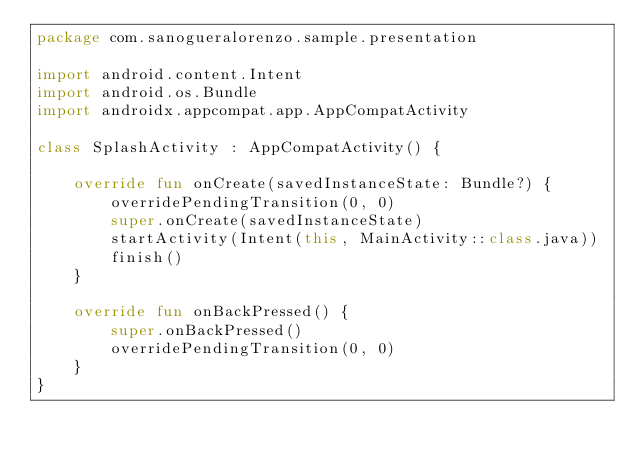<code> <loc_0><loc_0><loc_500><loc_500><_Kotlin_>package com.sanogueralorenzo.sample.presentation

import android.content.Intent
import android.os.Bundle
import androidx.appcompat.app.AppCompatActivity

class SplashActivity : AppCompatActivity() {

    override fun onCreate(savedInstanceState: Bundle?) {
        overridePendingTransition(0, 0)
        super.onCreate(savedInstanceState)
        startActivity(Intent(this, MainActivity::class.java))
        finish()
    }

    override fun onBackPressed() {
        super.onBackPressed()
        overridePendingTransition(0, 0)
    }
}
</code> 